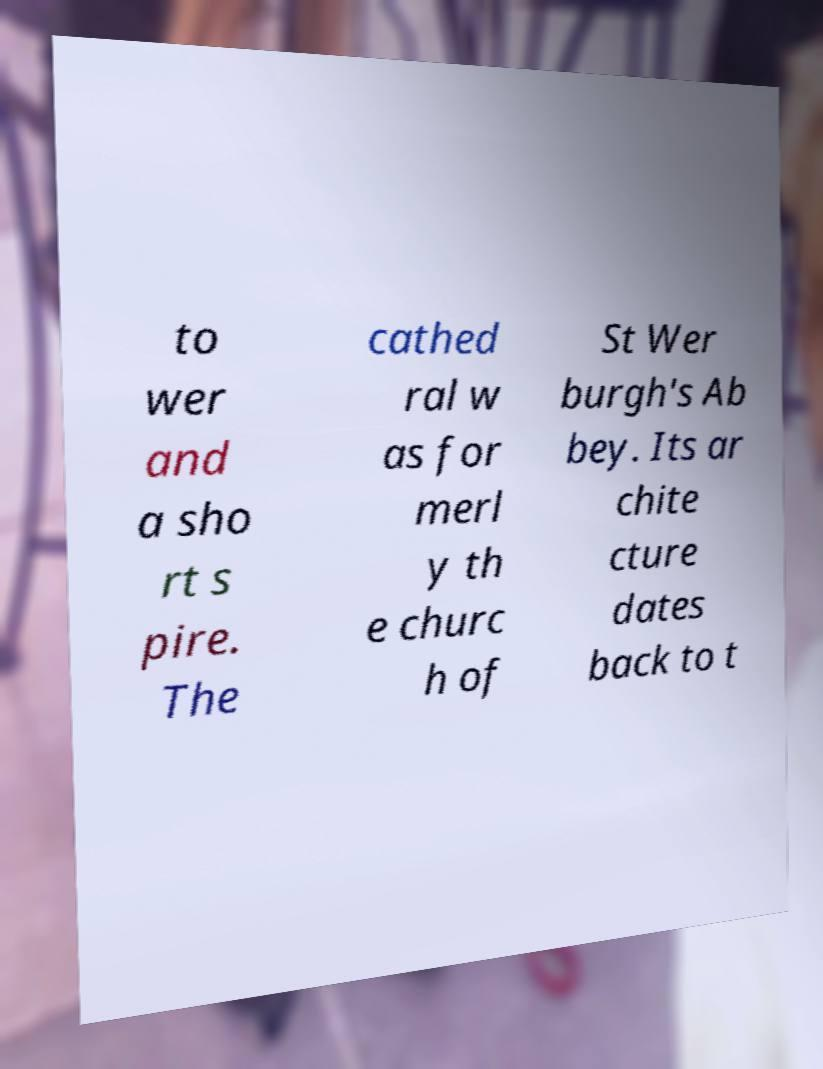Can you read and provide the text displayed in the image?This photo seems to have some interesting text. Can you extract and type it out for me? to wer and a sho rt s pire. The cathed ral w as for merl y th e churc h of St Wer burgh's Ab bey. Its ar chite cture dates back to t 